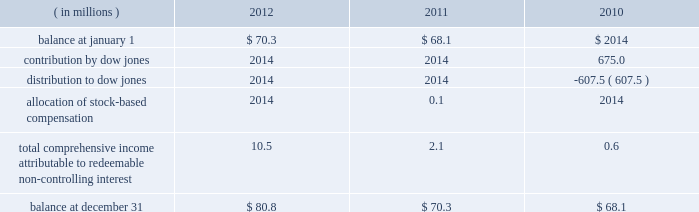Positions and collateral of the defaulting firm at each respective clearing organization , and taking into account any cross-margining loss sharing payments , any of the participating clearing organizations has a remaining liquidating surplus , and any other participating clearing organization has a remaining liquidating deficit , any additional surplus from the liquidation would be shared with the other clearing house to the extent that it has a remaining liquidating deficit .
Any remaining surplus funds would be passed to the bankruptcy trustee .
Mf global bankruptcy trust .
The company provided a $ 550.0 million financial guarantee to the bankruptcy trustee of mf global to accelerate the distribution of funds to mf global customers .
In the event that the trustee distributed more property in the second or third interim distributions than was permitted by the bankruptcy code and cftc regulations , the company will make a cash payment to the trustee for the amount of the erroneous distribution or distributions up to $ 550.0 million in the aggregate .
A payment will only be made after the trustee makes reasonable efforts to collect the property erroneously distributed to the customer ( s ) .
If a payment is made by the company , the company may have the right to seek reimbursement of the erroneously distributed property from the applicable customer ( s ) .
The guarantee does not cover distributions made by the trustee to customers on the basis of their claims filed in the bankruptcy .
Because the trustee has now made payments to nearly all customers on the basis of their claims , the company believes that the likelihood of payment to the trustee is very remote .
As a result , the guarantee liability is estimated to be immaterial at december 31 , 2012 .
Family farmer and rancher protection fund .
In april 2012 , the company established the family farmer and rancher protection fund ( the fund ) .
The fund is designed to provide payments , up to certain maximum levels , to family farmers , ranchers and other agricultural industry participants who use cme group agricultural products and who suffer losses to their segregated account balances due to their cme clearing member becoming insolvent .
Under the terms of the fund , farmers and ranchers are eligible for up to $ 25000 per participant .
Farming and ranching cooperatives are eligible for up to $ 100000 per cooperative .
The fund has an aggregate maximum payment amount of $ 100.0 million .
If payments to participants were to exceed this amount , payments would be pro-rated .
Clearing members and customers must register in advance with the company and provide certain documentation in order to substantiate their eligibility .
Peregrine financial group , inc .
( pfg ) filed for bankruptcy protection on july 10 , 2012 .
Pfg was not one of cme 2019s clearing members and its customers had not registered for the fund .
Accordingly , they were not technically eligible for payments from the fund .
However , because the fund was newly implemented and because pfg 2019s customers included many agricultural industry participants for whom the program was designed , the company decided to waive certain terms and conditions of the fund , solely in connection with the pfg bankruptcy , so that otherwise eligible family farmers , ranchers and agricultural cooperatives could apply for and receive benefits from cme .
Based on the number of such pfg customers who applied and the estimated size of their claims , the company has recorded a liability in the amount of $ 2.1 million at december 31 , 2012 .
16 .
Redeemable non-controlling interest the following summarizes the changes in redeemable non-controlling interest for the years presented .
Non- controlling interests that do not contain redemption features are presented in the statements of equity. .
Contribution by dow jones .
2014 2014 675.0 distribution to dow jones .
2014 2014 ( 607.5 ) allocation of stock- compensation .
2014 0.1 2014 total comprehensive income attributable to redeemable non- controlling interest .
10.5 2.1 0.6 balance at december 31 .
$ 80.8 $ 70.3 $ 68.1 .
What is the percentage change in the balance of non-controlling interests from 2010 to 2011? 
Computations: ((70.3 - 68.1) / 68.1)
Answer: 0.03231. Positions and collateral of the defaulting firm at each respective clearing organization , and taking into account any cross-margining loss sharing payments , any of the participating clearing organizations has a remaining liquidating surplus , and any other participating clearing organization has a remaining liquidating deficit , any additional surplus from the liquidation would be shared with the other clearing house to the extent that it has a remaining liquidating deficit .
Any remaining surplus funds would be passed to the bankruptcy trustee .
Mf global bankruptcy trust .
The company provided a $ 550.0 million financial guarantee to the bankruptcy trustee of mf global to accelerate the distribution of funds to mf global customers .
In the event that the trustee distributed more property in the second or third interim distributions than was permitted by the bankruptcy code and cftc regulations , the company will make a cash payment to the trustee for the amount of the erroneous distribution or distributions up to $ 550.0 million in the aggregate .
A payment will only be made after the trustee makes reasonable efforts to collect the property erroneously distributed to the customer ( s ) .
If a payment is made by the company , the company may have the right to seek reimbursement of the erroneously distributed property from the applicable customer ( s ) .
The guarantee does not cover distributions made by the trustee to customers on the basis of their claims filed in the bankruptcy .
Because the trustee has now made payments to nearly all customers on the basis of their claims , the company believes that the likelihood of payment to the trustee is very remote .
As a result , the guarantee liability is estimated to be immaterial at december 31 , 2012 .
Family farmer and rancher protection fund .
In april 2012 , the company established the family farmer and rancher protection fund ( the fund ) .
The fund is designed to provide payments , up to certain maximum levels , to family farmers , ranchers and other agricultural industry participants who use cme group agricultural products and who suffer losses to their segregated account balances due to their cme clearing member becoming insolvent .
Under the terms of the fund , farmers and ranchers are eligible for up to $ 25000 per participant .
Farming and ranching cooperatives are eligible for up to $ 100000 per cooperative .
The fund has an aggregate maximum payment amount of $ 100.0 million .
If payments to participants were to exceed this amount , payments would be pro-rated .
Clearing members and customers must register in advance with the company and provide certain documentation in order to substantiate their eligibility .
Peregrine financial group , inc .
( pfg ) filed for bankruptcy protection on july 10 , 2012 .
Pfg was not one of cme 2019s clearing members and its customers had not registered for the fund .
Accordingly , they were not technically eligible for payments from the fund .
However , because the fund was newly implemented and because pfg 2019s customers included many agricultural industry participants for whom the program was designed , the company decided to waive certain terms and conditions of the fund , solely in connection with the pfg bankruptcy , so that otherwise eligible family farmers , ranchers and agricultural cooperatives could apply for and receive benefits from cme .
Based on the number of such pfg customers who applied and the estimated size of their claims , the company has recorded a liability in the amount of $ 2.1 million at december 31 , 2012 .
16 .
Redeemable non-controlling interest the following summarizes the changes in redeemable non-controlling interest for the years presented .
Non- controlling interests that do not contain redemption features are presented in the statements of equity. .
Contribution by dow jones .
2014 2014 675.0 distribution to dow jones .
2014 2014 ( 607.5 ) allocation of stock- compensation .
2014 0.1 2014 total comprehensive income attributable to redeemable non- controlling interest .
10.5 2.1 0.6 balance at december 31 .
$ 80.8 $ 70.3 $ 68.1 .
What is the percentage change in the balance of non-controlling interests from 2011 to 2012? 
Computations: ((80.8 - 70.3) / 80.8)
Answer: 0.12995. 